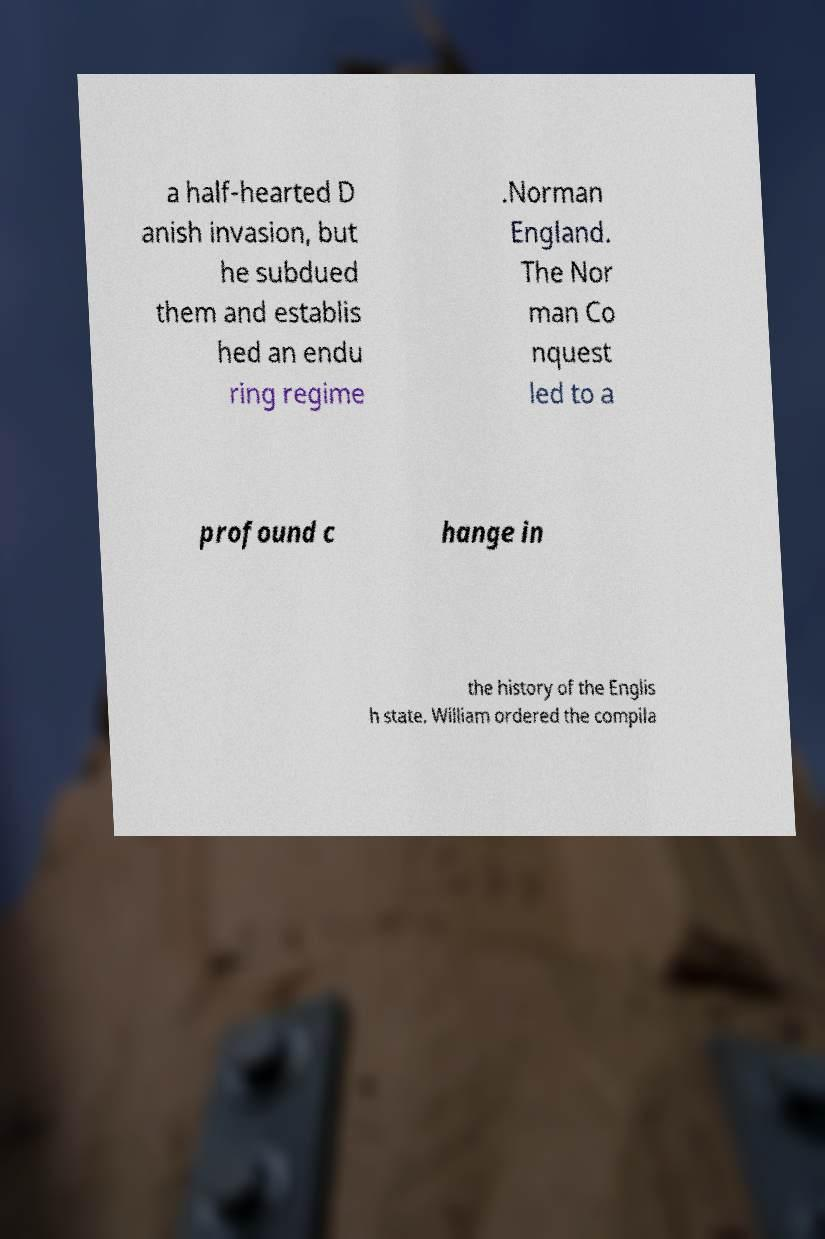I need the written content from this picture converted into text. Can you do that? a half-hearted D anish invasion, but he subdued them and establis hed an endu ring regime .Norman England. The Nor man Co nquest led to a profound c hange in the history of the Englis h state. William ordered the compila 